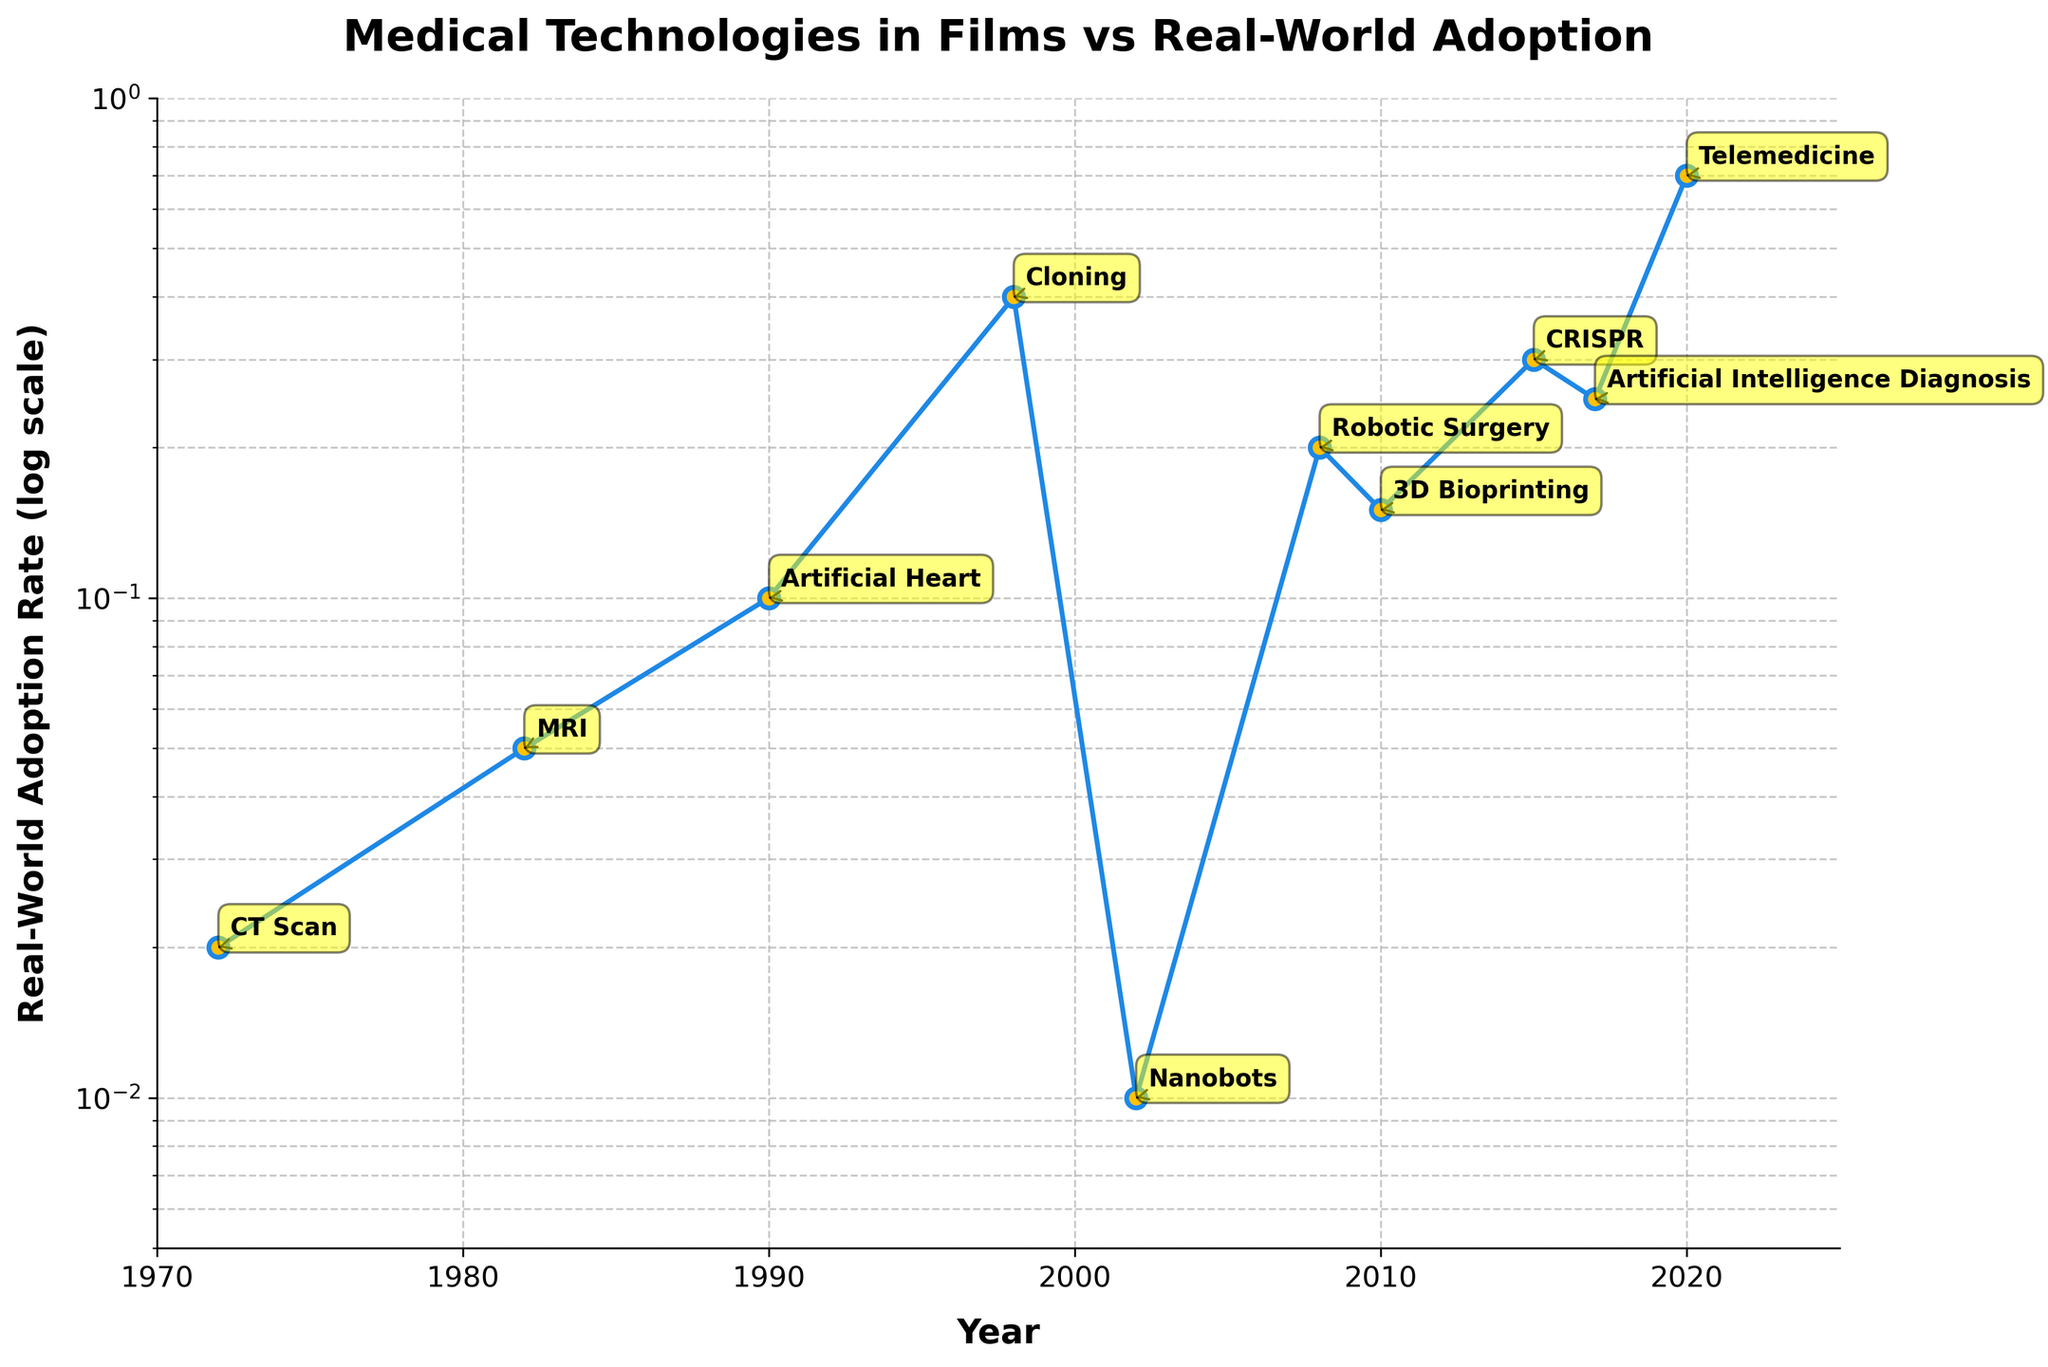What is the title of the plot? The title is located at the top of the figure and provides an overview of what the plot represents. The title of the plot is "Medical Technologies in Films vs Real-World Adoption."
Answer: Medical Technologies in Films vs Real-World Adoption Which technology has the highest real-world adoption rate in 2020? Look at the data points along the year 2020 on the x-axis and find the corresponding technology label with the highest y-value. The technology with the highest real-world adoption rate in 2020 is Telemedicine.
Answer: Telemedicine How many different technologies are depicted in the plot? Count the number of unique technology labels annotated on the plot. There are ten different technologies depicted in the plot.
Answer: Ten What is the adoption rate of Robotic Surgery according to the plot? Locate the data point corresponding to Robotic Surgery on the y-axis to determine its adoption rate. The adoption rate of Robotic Surgery is 0.20.
Answer: 0.20 Which technology had the lowest real-world adoption rate, and in what year was it portrayed in films? Identify the data point with the lowest y-value and note its corresponding year and technology label. The technology with the lowest real-world adoption rate is Nanobots, portrayed in the film Minority Report in 2002.
Answer: Nanobots in 2002 Compare the real-world adoption rates of Cloning and Nanobots. Which one is higher, and by how much? Identify the adoption rates of Cloning and Nanobots, then calculate the difference between them. Cloning has an adoption rate of 0.40 and Nanobots have an adoption rate of 0.01. Cloning is higher by 0.39.
Answer: Cloning by 0.39 In which decade did the most significant advancement in adoption rate occur? Examine the y-axis changes over the decades and identify which decade shows the largest increase in real-world adoption rates. The most significant advancement occurred in the decade of 2010-2020.
Answer: 2010-2020 What is the adoption rate difference between Artificial Intelligence Diagnosis and Telemedicine? Find the adoption rates of both technologies and subtract one value from the other. The adoption rates are 0.25 for Artificial Intelligence Diagnosis and 0.70 for Telemedicine. The difference is 0.70 - 0.25 = 0.45.
Answer: 0.45 How does the adoption rate of 3D Bioprinting compare to that of CRISPR? Compare the y-values of the data points for 3D Bioprinting and CRISPR. The adoption rate for 3D Bioprinting is 0.15, while for CRISPR it is 0.30. CRISPR has a higher adoption rate than 3D Bioprinting.
Answer: CRISPR is higher 